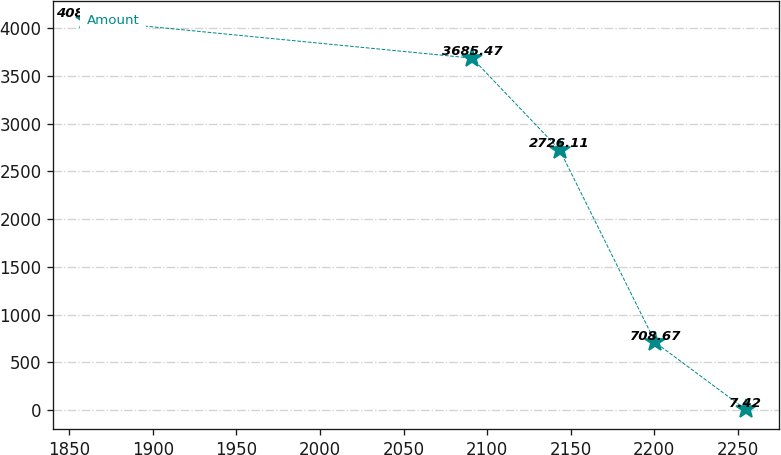Convert chart to OTSL. <chart><loc_0><loc_0><loc_500><loc_500><line_chart><ecel><fcel>Amount<nl><fcel>1860.13<fcel>4081.57<nl><fcel>2091.14<fcel>3685.47<nl><fcel>2143.43<fcel>2726.11<nl><fcel>2200.74<fcel>708.67<nl><fcel>2254.76<fcel>7.42<nl></chart> 